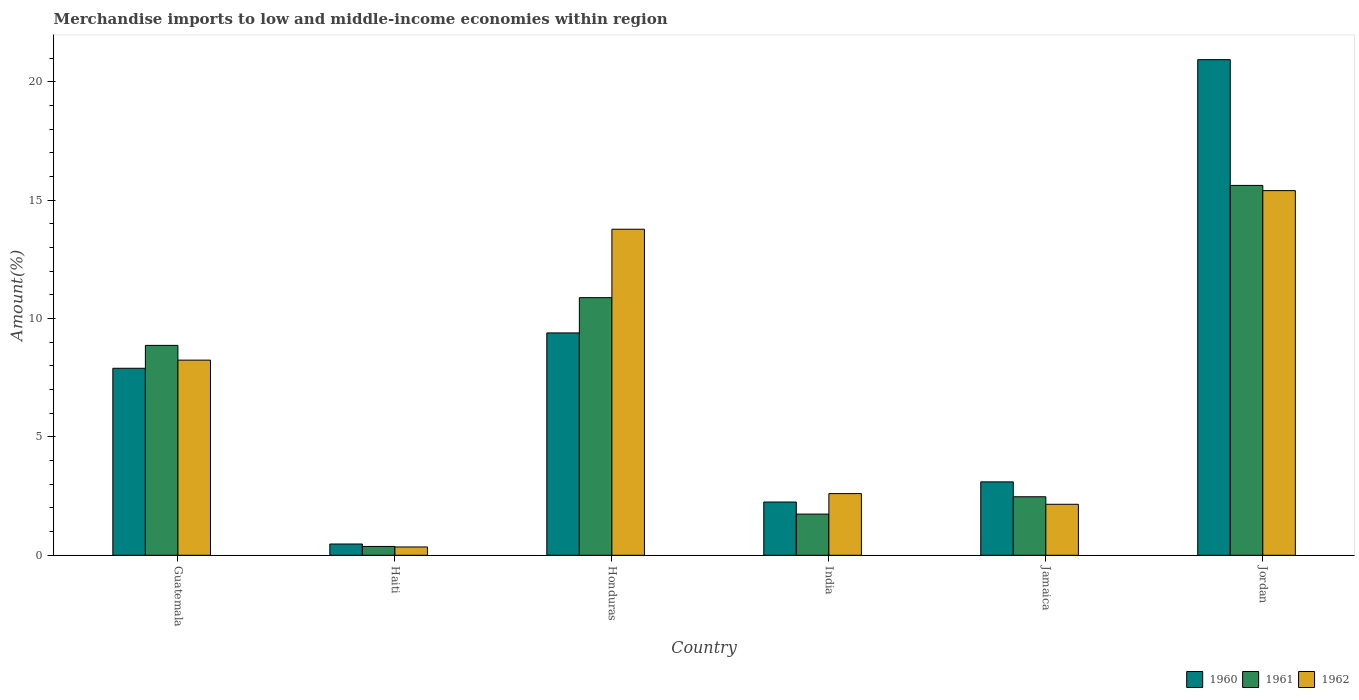How many different coloured bars are there?
Keep it short and to the point. 3. Are the number of bars per tick equal to the number of legend labels?
Offer a very short reply. Yes. Are the number of bars on each tick of the X-axis equal?
Offer a very short reply. Yes. How many bars are there on the 6th tick from the right?
Provide a short and direct response. 3. What is the label of the 5th group of bars from the left?
Your answer should be very brief. Jamaica. What is the percentage of amount earned from merchandise imports in 1960 in India?
Your answer should be very brief. 2.25. Across all countries, what is the maximum percentage of amount earned from merchandise imports in 1962?
Provide a short and direct response. 15.4. Across all countries, what is the minimum percentage of amount earned from merchandise imports in 1960?
Provide a succinct answer. 0.48. In which country was the percentage of amount earned from merchandise imports in 1962 maximum?
Your answer should be compact. Jordan. In which country was the percentage of amount earned from merchandise imports in 1961 minimum?
Offer a very short reply. Haiti. What is the total percentage of amount earned from merchandise imports in 1962 in the graph?
Make the answer very short. 42.53. What is the difference between the percentage of amount earned from merchandise imports in 1960 in India and that in Jordan?
Offer a terse response. -18.68. What is the difference between the percentage of amount earned from merchandise imports in 1960 in Jordan and the percentage of amount earned from merchandise imports in 1961 in Guatemala?
Keep it short and to the point. 12.07. What is the average percentage of amount earned from merchandise imports in 1962 per country?
Your response must be concise. 7.09. What is the difference between the percentage of amount earned from merchandise imports of/in 1962 and percentage of amount earned from merchandise imports of/in 1961 in Jordan?
Your response must be concise. -0.22. What is the ratio of the percentage of amount earned from merchandise imports in 1960 in Honduras to that in Jordan?
Your response must be concise. 0.45. Is the percentage of amount earned from merchandise imports in 1960 in Guatemala less than that in India?
Give a very brief answer. No. Is the difference between the percentage of amount earned from merchandise imports in 1962 in Honduras and India greater than the difference between the percentage of amount earned from merchandise imports in 1961 in Honduras and India?
Your answer should be compact. Yes. What is the difference between the highest and the second highest percentage of amount earned from merchandise imports in 1960?
Provide a succinct answer. -11.54. What is the difference between the highest and the lowest percentage of amount earned from merchandise imports in 1961?
Provide a short and direct response. 15.25. In how many countries, is the percentage of amount earned from merchandise imports in 1961 greater than the average percentage of amount earned from merchandise imports in 1961 taken over all countries?
Your answer should be very brief. 3. Is it the case that in every country, the sum of the percentage of amount earned from merchandise imports in 1960 and percentage of amount earned from merchandise imports in 1962 is greater than the percentage of amount earned from merchandise imports in 1961?
Your answer should be compact. Yes. How many bars are there?
Provide a succinct answer. 18. Are all the bars in the graph horizontal?
Offer a very short reply. No. How many countries are there in the graph?
Offer a very short reply. 6. Does the graph contain any zero values?
Provide a short and direct response. No. Does the graph contain grids?
Provide a succinct answer. No. How many legend labels are there?
Offer a terse response. 3. What is the title of the graph?
Offer a terse response. Merchandise imports to low and middle-income economies within region. Does "2014" appear as one of the legend labels in the graph?
Offer a terse response. No. What is the label or title of the Y-axis?
Your answer should be very brief. Amount(%). What is the Amount(%) in 1960 in Guatemala?
Offer a terse response. 7.9. What is the Amount(%) of 1961 in Guatemala?
Your answer should be compact. 8.87. What is the Amount(%) of 1962 in Guatemala?
Give a very brief answer. 8.24. What is the Amount(%) in 1960 in Haiti?
Ensure brevity in your answer.  0.48. What is the Amount(%) in 1961 in Haiti?
Give a very brief answer. 0.37. What is the Amount(%) in 1962 in Haiti?
Your response must be concise. 0.35. What is the Amount(%) in 1960 in Honduras?
Ensure brevity in your answer.  9.39. What is the Amount(%) of 1961 in Honduras?
Offer a terse response. 10.88. What is the Amount(%) in 1962 in Honduras?
Your answer should be compact. 13.77. What is the Amount(%) of 1960 in India?
Offer a terse response. 2.25. What is the Amount(%) of 1961 in India?
Make the answer very short. 1.74. What is the Amount(%) of 1962 in India?
Provide a succinct answer. 2.6. What is the Amount(%) of 1960 in Jamaica?
Your answer should be compact. 3.1. What is the Amount(%) in 1961 in Jamaica?
Your response must be concise. 2.47. What is the Amount(%) in 1962 in Jamaica?
Keep it short and to the point. 2.15. What is the Amount(%) in 1960 in Jordan?
Make the answer very short. 20.93. What is the Amount(%) in 1961 in Jordan?
Your response must be concise. 15.62. What is the Amount(%) in 1962 in Jordan?
Your answer should be very brief. 15.4. Across all countries, what is the maximum Amount(%) of 1960?
Make the answer very short. 20.93. Across all countries, what is the maximum Amount(%) in 1961?
Your answer should be very brief. 15.62. Across all countries, what is the maximum Amount(%) of 1962?
Your answer should be compact. 15.4. Across all countries, what is the minimum Amount(%) in 1960?
Provide a succinct answer. 0.48. Across all countries, what is the minimum Amount(%) in 1961?
Offer a very short reply. 0.37. Across all countries, what is the minimum Amount(%) in 1962?
Offer a very short reply. 0.35. What is the total Amount(%) of 1960 in the graph?
Provide a short and direct response. 44.05. What is the total Amount(%) in 1961 in the graph?
Keep it short and to the point. 39.95. What is the total Amount(%) in 1962 in the graph?
Make the answer very short. 42.53. What is the difference between the Amount(%) in 1960 in Guatemala and that in Haiti?
Provide a succinct answer. 7.42. What is the difference between the Amount(%) in 1961 in Guatemala and that in Haiti?
Provide a succinct answer. 8.49. What is the difference between the Amount(%) of 1962 in Guatemala and that in Haiti?
Your answer should be compact. 7.89. What is the difference between the Amount(%) in 1960 in Guatemala and that in Honduras?
Your response must be concise. -1.49. What is the difference between the Amount(%) in 1961 in Guatemala and that in Honduras?
Offer a very short reply. -2.02. What is the difference between the Amount(%) in 1962 in Guatemala and that in Honduras?
Provide a succinct answer. -5.53. What is the difference between the Amount(%) in 1960 in Guatemala and that in India?
Make the answer very short. 5.65. What is the difference between the Amount(%) of 1961 in Guatemala and that in India?
Offer a terse response. 7.13. What is the difference between the Amount(%) of 1962 in Guatemala and that in India?
Provide a short and direct response. 5.64. What is the difference between the Amount(%) in 1960 in Guatemala and that in Jamaica?
Offer a terse response. 4.8. What is the difference between the Amount(%) in 1961 in Guatemala and that in Jamaica?
Provide a short and direct response. 6.39. What is the difference between the Amount(%) of 1962 in Guatemala and that in Jamaica?
Offer a terse response. 6.09. What is the difference between the Amount(%) of 1960 in Guatemala and that in Jordan?
Keep it short and to the point. -13.04. What is the difference between the Amount(%) of 1961 in Guatemala and that in Jordan?
Your answer should be compact. -6.76. What is the difference between the Amount(%) in 1962 in Guatemala and that in Jordan?
Offer a very short reply. -7.16. What is the difference between the Amount(%) of 1960 in Haiti and that in Honduras?
Your answer should be compact. -8.92. What is the difference between the Amount(%) of 1961 in Haiti and that in Honduras?
Keep it short and to the point. -10.51. What is the difference between the Amount(%) in 1962 in Haiti and that in Honduras?
Offer a terse response. -13.42. What is the difference between the Amount(%) of 1960 in Haiti and that in India?
Keep it short and to the point. -1.77. What is the difference between the Amount(%) in 1961 in Haiti and that in India?
Provide a succinct answer. -1.37. What is the difference between the Amount(%) of 1962 in Haiti and that in India?
Ensure brevity in your answer.  -2.25. What is the difference between the Amount(%) in 1960 in Haiti and that in Jamaica?
Make the answer very short. -2.62. What is the difference between the Amount(%) of 1961 in Haiti and that in Jamaica?
Your response must be concise. -2.1. What is the difference between the Amount(%) of 1962 in Haiti and that in Jamaica?
Provide a short and direct response. -1.8. What is the difference between the Amount(%) in 1960 in Haiti and that in Jordan?
Offer a very short reply. -20.46. What is the difference between the Amount(%) of 1961 in Haiti and that in Jordan?
Your answer should be compact. -15.25. What is the difference between the Amount(%) of 1962 in Haiti and that in Jordan?
Offer a very short reply. -15.05. What is the difference between the Amount(%) of 1960 in Honduras and that in India?
Make the answer very short. 7.14. What is the difference between the Amount(%) of 1961 in Honduras and that in India?
Your response must be concise. 9.14. What is the difference between the Amount(%) of 1962 in Honduras and that in India?
Provide a succinct answer. 11.17. What is the difference between the Amount(%) of 1960 in Honduras and that in Jamaica?
Provide a short and direct response. 6.29. What is the difference between the Amount(%) in 1961 in Honduras and that in Jamaica?
Provide a succinct answer. 8.41. What is the difference between the Amount(%) in 1962 in Honduras and that in Jamaica?
Offer a very short reply. 11.62. What is the difference between the Amount(%) of 1960 in Honduras and that in Jordan?
Your answer should be very brief. -11.54. What is the difference between the Amount(%) in 1961 in Honduras and that in Jordan?
Your answer should be very brief. -4.74. What is the difference between the Amount(%) of 1962 in Honduras and that in Jordan?
Your answer should be very brief. -1.63. What is the difference between the Amount(%) of 1960 in India and that in Jamaica?
Your answer should be compact. -0.85. What is the difference between the Amount(%) of 1961 in India and that in Jamaica?
Offer a very short reply. -0.73. What is the difference between the Amount(%) in 1962 in India and that in Jamaica?
Make the answer very short. 0.45. What is the difference between the Amount(%) of 1960 in India and that in Jordan?
Provide a short and direct response. -18.68. What is the difference between the Amount(%) of 1961 in India and that in Jordan?
Provide a succinct answer. -13.88. What is the difference between the Amount(%) of 1962 in India and that in Jordan?
Provide a short and direct response. -12.8. What is the difference between the Amount(%) of 1960 in Jamaica and that in Jordan?
Provide a succinct answer. -17.83. What is the difference between the Amount(%) in 1961 in Jamaica and that in Jordan?
Offer a very short reply. -13.15. What is the difference between the Amount(%) in 1962 in Jamaica and that in Jordan?
Your answer should be very brief. -13.25. What is the difference between the Amount(%) in 1960 in Guatemala and the Amount(%) in 1961 in Haiti?
Make the answer very short. 7.53. What is the difference between the Amount(%) of 1960 in Guatemala and the Amount(%) of 1962 in Haiti?
Provide a short and direct response. 7.55. What is the difference between the Amount(%) in 1961 in Guatemala and the Amount(%) in 1962 in Haiti?
Make the answer very short. 8.51. What is the difference between the Amount(%) of 1960 in Guatemala and the Amount(%) of 1961 in Honduras?
Keep it short and to the point. -2.98. What is the difference between the Amount(%) of 1960 in Guatemala and the Amount(%) of 1962 in Honduras?
Ensure brevity in your answer.  -5.87. What is the difference between the Amount(%) in 1961 in Guatemala and the Amount(%) in 1962 in Honduras?
Give a very brief answer. -4.91. What is the difference between the Amount(%) of 1960 in Guatemala and the Amount(%) of 1961 in India?
Provide a short and direct response. 6.16. What is the difference between the Amount(%) in 1960 in Guatemala and the Amount(%) in 1962 in India?
Give a very brief answer. 5.29. What is the difference between the Amount(%) in 1961 in Guatemala and the Amount(%) in 1962 in India?
Offer a very short reply. 6.26. What is the difference between the Amount(%) in 1960 in Guatemala and the Amount(%) in 1961 in Jamaica?
Offer a very short reply. 5.43. What is the difference between the Amount(%) of 1960 in Guatemala and the Amount(%) of 1962 in Jamaica?
Ensure brevity in your answer.  5.75. What is the difference between the Amount(%) in 1961 in Guatemala and the Amount(%) in 1962 in Jamaica?
Ensure brevity in your answer.  6.71. What is the difference between the Amount(%) in 1960 in Guatemala and the Amount(%) in 1961 in Jordan?
Provide a succinct answer. -7.72. What is the difference between the Amount(%) of 1960 in Guatemala and the Amount(%) of 1962 in Jordan?
Provide a succinct answer. -7.5. What is the difference between the Amount(%) in 1961 in Guatemala and the Amount(%) in 1962 in Jordan?
Keep it short and to the point. -6.54. What is the difference between the Amount(%) of 1960 in Haiti and the Amount(%) of 1961 in Honduras?
Your answer should be compact. -10.41. What is the difference between the Amount(%) in 1960 in Haiti and the Amount(%) in 1962 in Honduras?
Your answer should be compact. -13.3. What is the difference between the Amount(%) of 1961 in Haiti and the Amount(%) of 1962 in Honduras?
Keep it short and to the point. -13.4. What is the difference between the Amount(%) of 1960 in Haiti and the Amount(%) of 1961 in India?
Keep it short and to the point. -1.26. What is the difference between the Amount(%) in 1960 in Haiti and the Amount(%) in 1962 in India?
Keep it short and to the point. -2.13. What is the difference between the Amount(%) in 1961 in Haiti and the Amount(%) in 1962 in India?
Provide a short and direct response. -2.23. What is the difference between the Amount(%) in 1960 in Haiti and the Amount(%) in 1961 in Jamaica?
Your response must be concise. -2. What is the difference between the Amount(%) of 1960 in Haiti and the Amount(%) of 1962 in Jamaica?
Ensure brevity in your answer.  -1.68. What is the difference between the Amount(%) of 1961 in Haiti and the Amount(%) of 1962 in Jamaica?
Ensure brevity in your answer.  -1.78. What is the difference between the Amount(%) of 1960 in Haiti and the Amount(%) of 1961 in Jordan?
Ensure brevity in your answer.  -15.15. What is the difference between the Amount(%) in 1960 in Haiti and the Amount(%) in 1962 in Jordan?
Keep it short and to the point. -14.93. What is the difference between the Amount(%) in 1961 in Haiti and the Amount(%) in 1962 in Jordan?
Offer a very short reply. -15.03. What is the difference between the Amount(%) in 1960 in Honduras and the Amount(%) in 1961 in India?
Your answer should be compact. 7.65. What is the difference between the Amount(%) in 1960 in Honduras and the Amount(%) in 1962 in India?
Keep it short and to the point. 6.79. What is the difference between the Amount(%) in 1961 in Honduras and the Amount(%) in 1962 in India?
Provide a short and direct response. 8.28. What is the difference between the Amount(%) of 1960 in Honduras and the Amount(%) of 1961 in Jamaica?
Keep it short and to the point. 6.92. What is the difference between the Amount(%) in 1960 in Honduras and the Amount(%) in 1962 in Jamaica?
Give a very brief answer. 7.24. What is the difference between the Amount(%) of 1961 in Honduras and the Amount(%) of 1962 in Jamaica?
Give a very brief answer. 8.73. What is the difference between the Amount(%) of 1960 in Honduras and the Amount(%) of 1961 in Jordan?
Ensure brevity in your answer.  -6.23. What is the difference between the Amount(%) of 1960 in Honduras and the Amount(%) of 1962 in Jordan?
Offer a terse response. -6.01. What is the difference between the Amount(%) in 1961 in Honduras and the Amount(%) in 1962 in Jordan?
Give a very brief answer. -4.52. What is the difference between the Amount(%) in 1960 in India and the Amount(%) in 1961 in Jamaica?
Give a very brief answer. -0.22. What is the difference between the Amount(%) in 1960 in India and the Amount(%) in 1962 in Jamaica?
Your answer should be very brief. 0.1. What is the difference between the Amount(%) in 1961 in India and the Amount(%) in 1962 in Jamaica?
Keep it short and to the point. -0.41. What is the difference between the Amount(%) in 1960 in India and the Amount(%) in 1961 in Jordan?
Provide a short and direct response. -13.37. What is the difference between the Amount(%) of 1960 in India and the Amount(%) of 1962 in Jordan?
Your answer should be compact. -13.15. What is the difference between the Amount(%) in 1961 in India and the Amount(%) in 1962 in Jordan?
Ensure brevity in your answer.  -13.66. What is the difference between the Amount(%) in 1960 in Jamaica and the Amount(%) in 1961 in Jordan?
Your answer should be compact. -12.52. What is the difference between the Amount(%) in 1960 in Jamaica and the Amount(%) in 1962 in Jordan?
Your response must be concise. -12.3. What is the difference between the Amount(%) in 1961 in Jamaica and the Amount(%) in 1962 in Jordan?
Ensure brevity in your answer.  -12.93. What is the average Amount(%) in 1960 per country?
Your response must be concise. 7.34. What is the average Amount(%) of 1961 per country?
Offer a very short reply. 6.66. What is the average Amount(%) of 1962 per country?
Your answer should be compact. 7.09. What is the difference between the Amount(%) of 1960 and Amount(%) of 1961 in Guatemala?
Keep it short and to the point. -0.97. What is the difference between the Amount(%) of 1960 and Amount(%) of 1962 in Guatemala?
Provide a succinct answer. -0.34. What is the difference between the Amount(%) in 1961 and Amount(%) in 1962 in Guatemala?
Ensure brevity in your answer.  0.62. What is the difference between the Amount(%) in 1960 and Amount(%) in 1961 in Haiti?
Your answer should be very brief. 0.1. What is the difference between the Amount(%) in 1960 and Amount(%) in 1962 in Haiti?
Keep it short and to the point. 0.12. What is the difference between the Amount(%) in 1961 and Amount(%) in 1962 in Haiti?
Your answer should be compact. 0.02. What is the difference between the Amount(%) of 1960 and Amount(%) of 1961 in Honduras?
Your answer should be very brief. -1.49. What is the difference between the Amount(%) in 1960 and Amount(%) in 1962 in Honduras?
Give a very brief answer. -4.38. What is the difference between the Amount(%) in 1961 and Amount(%) in 1962 in Honduras?
Your response must be concise. -2.89. What is the difference between the Amount(%) in 1960 and Amount(%) in 1961 in India?
Provide a short and direct response. 0.51. What is the difference between the Amount(%) in 1960 and Amount(%) in 1962 in India?
Offer a very short reply. -0.36. What is the difference between the Amount(%) of 1961 and Amount(%) of 1962 in India?
Your response must be concise. -0.87. What is the difference between the Amount(%) of 1960 and Amount(%) of 1961 in Jamaica?
Your answer should be compact. 0.63. What is the difference between the Amount(%) in 1960 and Amount(%) in 1962 in Jamaica?
Provide a short and direct response. 0.95. What is the difference between the Amount(%) of 1961 and Amount(%) of 1962 in Jamaica?
Ensure brevity in your answer.  0.32. What is the difference between the Amount(%) of 1960 and Amount(%) of 1961 in Jordan?
Your answer should be very brief. 5.31. What is the difference between the Amount(%) of 1960 and Amount(%) of 1962 in Jordan?
Keep it short and to the point. 5.53. What is the difference between the Amount(%) in 1961 and Amount(%) in 1962 in Jordan?
Offer a very short reply. 0.22. What is the ratio of the Amount(%) in 1960 in Guatemala to that in Haiti?
Make the answer very short. 16.61. What is the ratio of the Amount(%) in 1961 in Guatemala to that in Haiti?
Provide a succinct answer. 23.77. What is the ratio of the Amount(%) of 1962 in Guatemala to that in Haiti?
Give a very brief answer. 23.47. What is the ratio of the Amount(%) of 1960 in Guatemala to that in Honduras?
Provide a short and direct response. 0.84. What is the ratio of the Amount(%) in 1961 in Guatemala to that in Honduras?
Provide a short and direct response. 0.81. What is the ratio of the Amount(%) of 1962 in Guatemala to that in Honduras?
Your answer should be compact. 0.6. What is the ratio of the Amount(%) in 1960 in Guatemala to that in India?
Ensure brevity in your answer.  3.51. What is the ratio of the Amount(%) of 1961 in Guatemala to that in India?
Make the answer very short. 5.1. What is the ratio of the Amount(%) of 1962 in Guatemala to that in India?
Your answer should be compact. 3.16. What is the ratio of the Amount(%) in 1960 in Guatemala to that in Jamaica?
Keep it short and to the point. 2.55. What is the ratio of the Amount(%) of 1961 in Guatemala to that in Jamaica?
Your answer should be compact. 3.59. What is the ratio of the Amount(%) in 1962 in Guatemala to that in Jamaica?
Keep it short and to the point. 3.83. What is the ratio of the Amount(%) in 1960 in Guatemala to that in Jordan?
Provide a succinct answer. 0.38. What is the ratio of the Amount(%) of 1961 in Guatemala to that in Jordan?
Keep it short and to the point. 0.57. What is the ratio of the Amount(%) of 1962 in Guatemala to that in Jordan?
Ensure brevity in your answer.  0.54. What is the ratio of the Amount(%) of 1960 in Haiti to that in Honduras?
Keep it short and to the point. 0.05. What is the ratio of the Amount(%) in 1961 in Haiti to that in Honduras?
Provide a short and direct response. 0.03. What is the ratio of the Amount(%) of 1962 in Haiti to that in Honduras?
Ensure brevity in your answer.  0.03. What is the ratio of the Amount(%) in 1960 in Haiti to that in India?
Provide a succinct answer. 0.21. What is the ratio of the Amount(%) in 1961 in Haiti to that in India?
Your answer should be very brief. 0.21. What is the ratio of the Amount(%) of 1962 in Haiti to that in India?
Your answer should be very brief. 0.13. What is the ratio of the Amount(%) in 1960 in Haiti to that in Jamaica?
Ensure brevity in your answer.  0.15. What is the ratio of the Amount(%) in 1961 in Haiti to that in Jamaica?
Offer a very short reply. 0.15. What is the ratio of the Amount(%) in 1962 in Haiti to that in Jamaica?
Provide a succinct answer. 0.16. What is the ratio of the Amount(%) in 1960 in Haiti to that in Jordan?
Keep it short and to the point. 0.02. What is the ratio of the Amount(%) in 1961 in Haiti to that in Jordan?
Offer a very short reply. 0.02. What is the ratio of the Amount(%) of 1962 in Haiti to that in Jordan?
Keep it short and to the point. 0.02. What is the ratio of the Amount(%) of 1960 in Honduras to that in India?
Offer a very short reply. 4.18. What is the ratio of the Amount(%) in 1961 in Honduras to that in India?
Keep it short and to the point. 6.26. What is the ratio of the Amount(%) in 1962 in Honduras to that in India?
Give a very brief answer. 5.29. What is the ratio of the Amount(%) of 1960 in Honduras to that in Jamaica?
Provide a short and direct response. 3.03. What is the ratio of the Amount(%) in 1961 in Honduras to that in Jamaica?
Your answer should be very brief. 4.4. What is the ratio of the Amount(%) in 1962 in Honduras to that in Jamaica?
Your answer should be very brief. 6.4. What is the ratio of the Amount(%) in 1960 in Honduras to that in Jordan?
Make the answer very short. 0.45. What is the ratio of the Amount(%) of 1961 in Honduras to that in Jordan?
Your answer should be compact. 0.7. What is the ratio of the Amount(%) in 1962 in Honduras to that in Jordan?
Provide a short and direct response. 0.89. What is the ratio of the Amount(%) in 1960 in India to that in Jamaica?
Offer a terse response. 0.73. What is the ratio of the Amount(%) in 1961 in India to that in Jamaica?
Provide a succinct answer. 0.7. What is the ratio of the Amount(%) in 1962 in India to that in Jamaica?
Your response must be concise. 1.21. What is the ratio of the Amount(%) in 1960 in India to that in Jordan?
Offer a terse response. 0.11. What is the ratio of the Amount(%) in 1961 in India to that in Jordan?
Your answer should be compact. 0.11. What is the ratio of the Amount(%) in 1962 in India to that in Jordan?
Ensure brevity in your answer.  0.17. What is the ratio of the Amount(%) in 1960 in Jamaica to that in Jordan?
Offer a very short reply. 0.15. What is the ratio of the Amount(%) of 1961 in Jamaica to that in Jordan?
Your answer should be very brief. 0.16. What is the ratio of the Amount(%) in 1962 in Jamaica to that in Jordan?
Provide a succinct answer. 0.14. What is the difference between the highest and the second highest Amount(%) in 1960?
Offer a terse response. 11.54. What is the difference between the highest and the second highest Amount(%) of 1961?
Make the answer very short. 4.74. What is the difference between the highest and the second highest Amount(%) of 1962?
Give a very brief answer. 1.63. What is the difference between the highest and the lowest Amount(%) in 1960?
Provide a succinct answer. 20.46. What is the difference between the highest and the lowest Amount(%) of 1961?
Provide a succinct answer. 15.25. What is the difference between the highest and the lowest Amount(%) of 1962?
Keep it short and to the point. 15.05. 